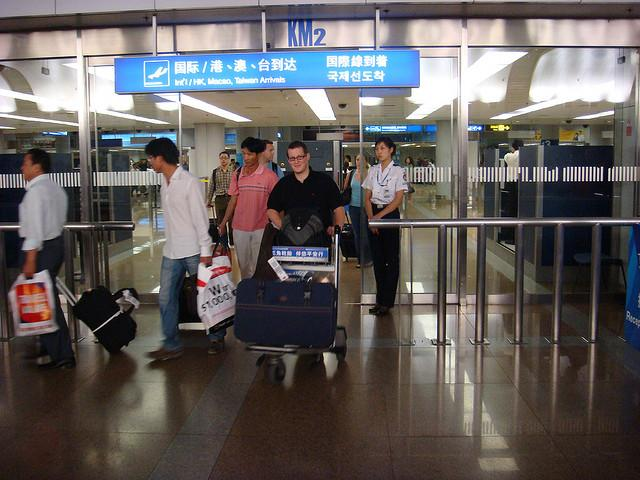What language is the sign in? Please explain your reasoning. chinese. The sign is in chinese. 